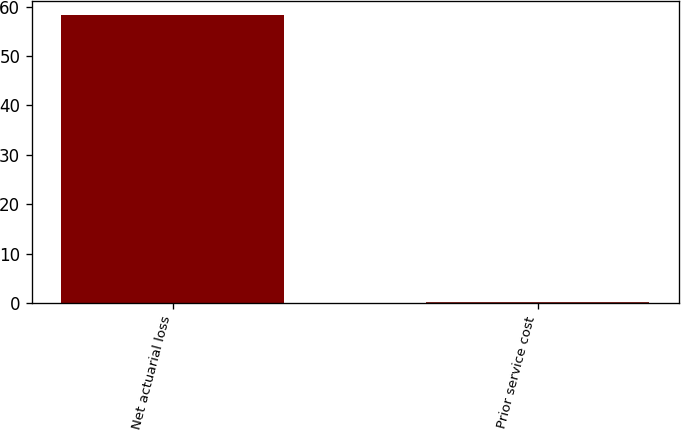Convert chart. <chart><loc_0><loc_0><loc_500><loc_500><bar_chart><fcel>Net actuarial loss<fcel>Prior service cost<nl><fcel>58.3<fcel>0.2<nl></chart> 